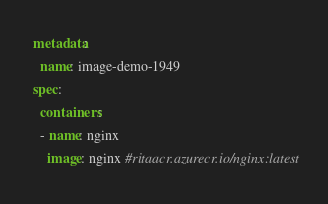Convert code to text. <code><loc_0><loc_0><loc_500><loc_500><_YAML_>metadata:
  name: image-demo-1949
spec:
  containers:
  - name: nginx
    image: nginx #ritaacr.azurecr.io/nginx:latest</code> 